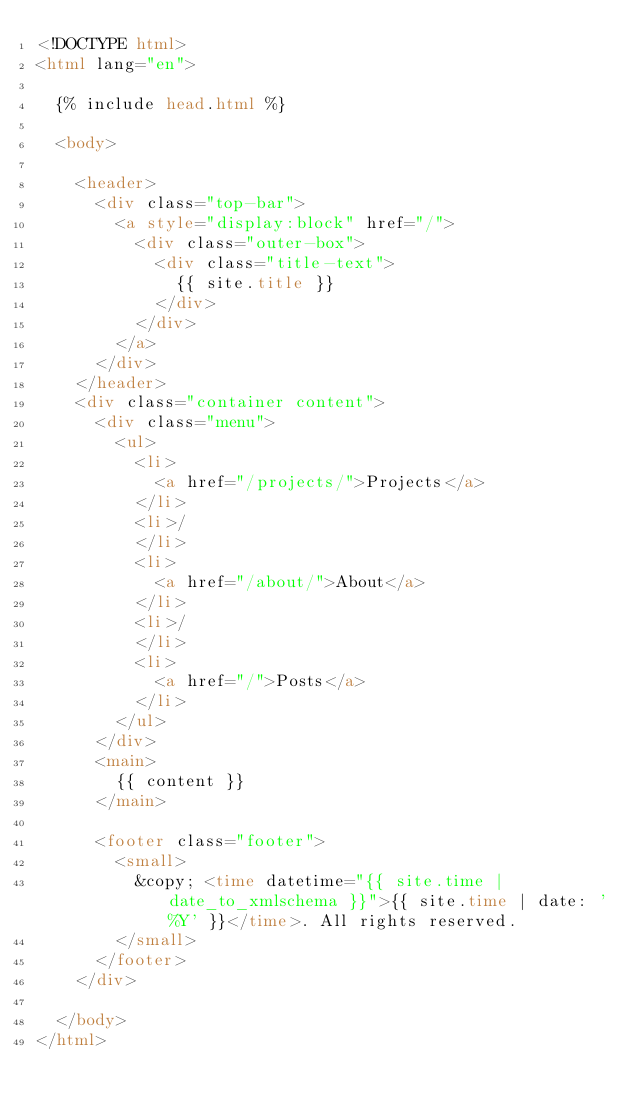Convert code to text. <code><loc_0><loc_0><loc_500><loc_500><_HTML_><!DOCTYPE html>
<html lang="en">

  {% include head.html %}

  <body>

    <header>
      <div class="top-bar">
        <a style="display:block" href="/">
          <div class="outer-box">
            <div class="title-text">
              {{ site.title }}
            </div>
          </div>
        </a>
      </div>
    </header>
    <div class="container content">
      <div class="menu">
        <ul>
          <li>
            <a href="/projects/">Projects</a>
          </li>
          <li>/
          </li>
          <li>
            <a href="/about/">About</a>
          </li>
          <li>/
          </li>
          <li>
            <a href="/">Posts</a>
          </li>
        </ul>
      </div>
      <main>
        {{ content }}
      </main>

      <footer class="footer">
        <small>
          &copy; <time datetime="{{ site.time | date_to_xmlschema }}">{{ site.time | date: '%Y' }}</time>. All rights reserved.
        </small>
      </footer>
    </div>

  </body>
</html>
</code> 